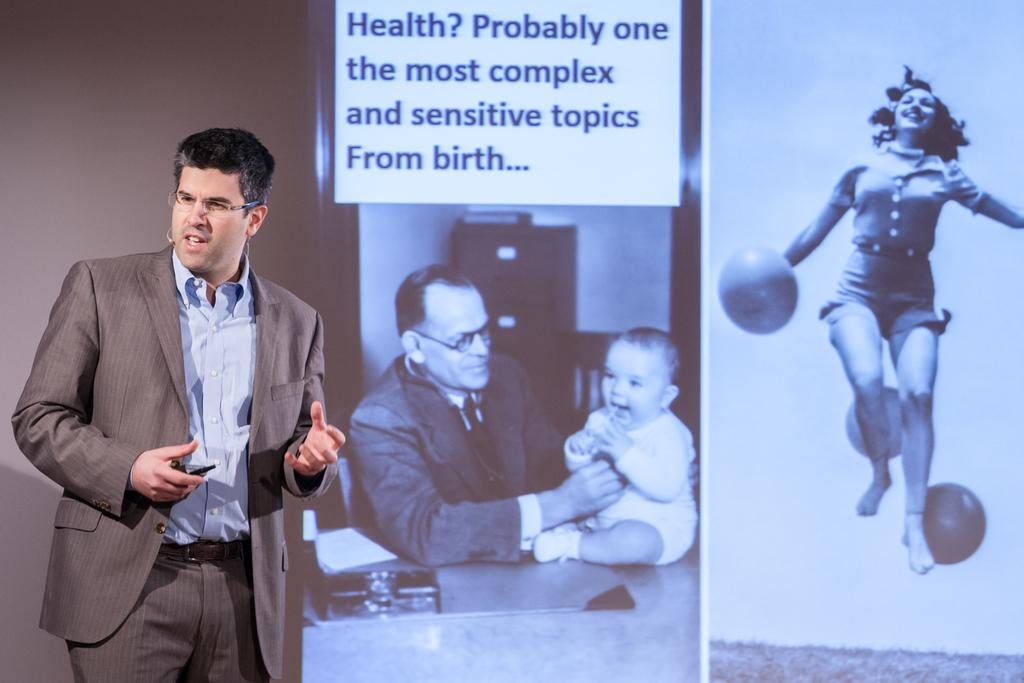Who is present in the image? There is a person in the image. What can be observed about the person's appearance? The person is wearing spectacles. What is visible in the background of the image? There is a screen in the background of the image. What is happening on the screen? There are people visible on the screen. What type of music can be heard coming from the church in the image? There is no church or music present in the image; it features a person with spectacles and a screen in the background. 